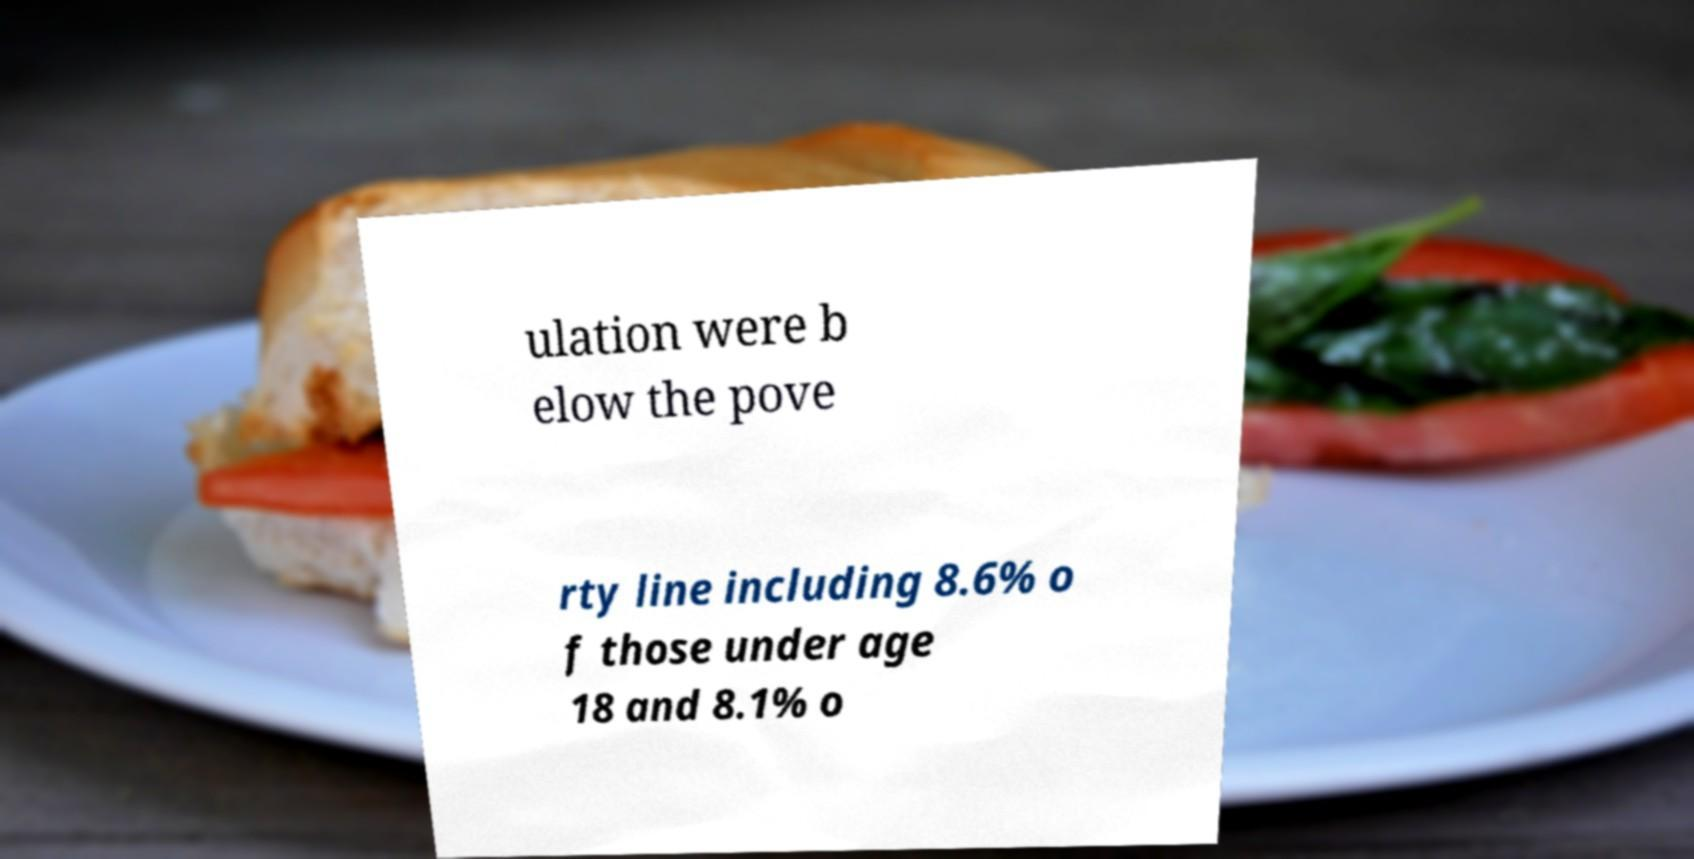Please identify and transcribe the text found in this image. ulation were b elow the pove rty line including 8.6% o f those under age 18 and 8.1% o 